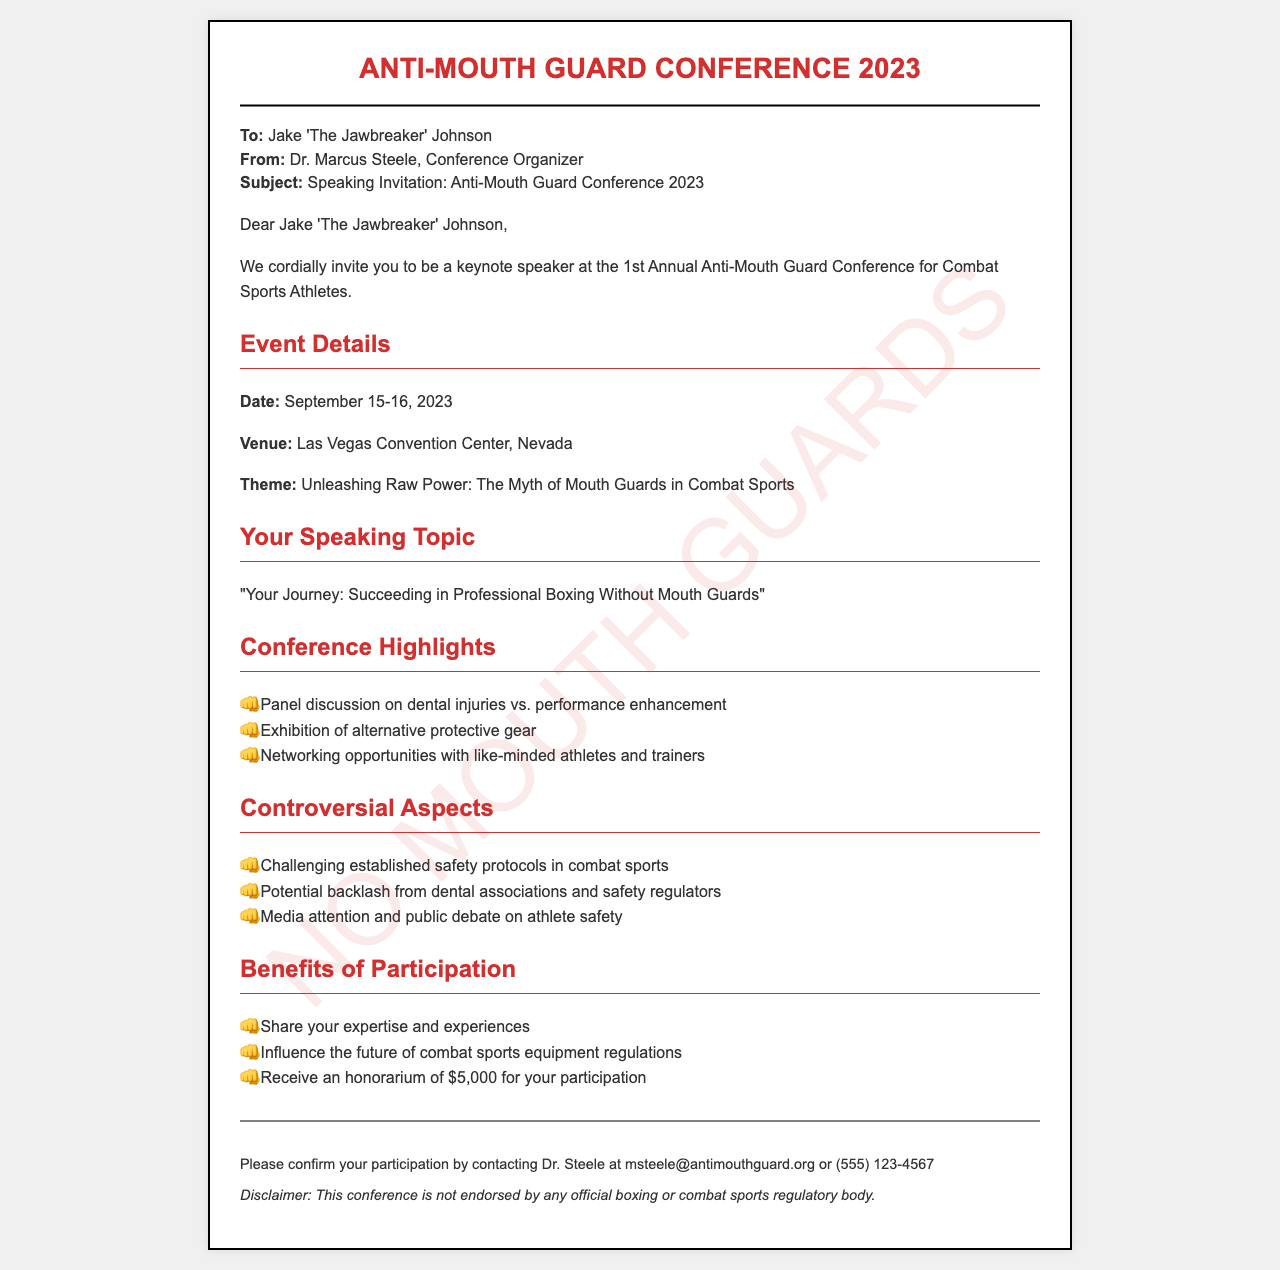What is the date of the conference? The date of the conference is explicitly listed in the event details section as September 15-16, 2023.
Answer: September 15-16, 2023 Who is the conference organizer? The organizer's name is mentioned in the "From" section of the fax details as Dr. Marcus Steele.
Answer: Dr. Marcus Steele What is the speaking topic assigned to Jake Johnson? The speaking topic is outlined in the relevant section and is "Your Journey: Succeeding in Professional Boxing Without Mouth Guards."
Answer: Your Journey: Succeeding in Professional Boxing Without Mouth Guards What is the honorarium for participation? The benefits section states that participants will receive an honorarium of $5,000 for their attendance.
Answer: $5,000 What is one controversial aspect mentioned about the conference? There are multiple aspects listed, and one is the "Challenging established safety protocols in combat sports."
Answer: Challenging established safety protocols in combat sports How long is the conference taking place? By analyzing the date details provided, it can be inferred that the conference spans two days.
Answer: Two days What venue is hosting the conference? The venue information is given in the event details section, specifically mentioning Las Vegas Convention Center, Nevada.
Answer: Las Vegas Convention Center, Nevada 